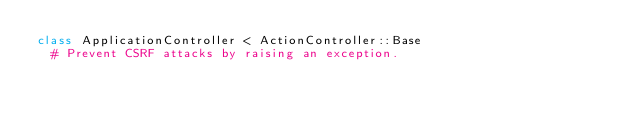Convert code to text. <code><loc_0><loc_0><loc_500><loc_500><_Ruby_>class ApplicationController < ActionController::Base
  # Prevent CSRF attacks by raising an exception.</code> 